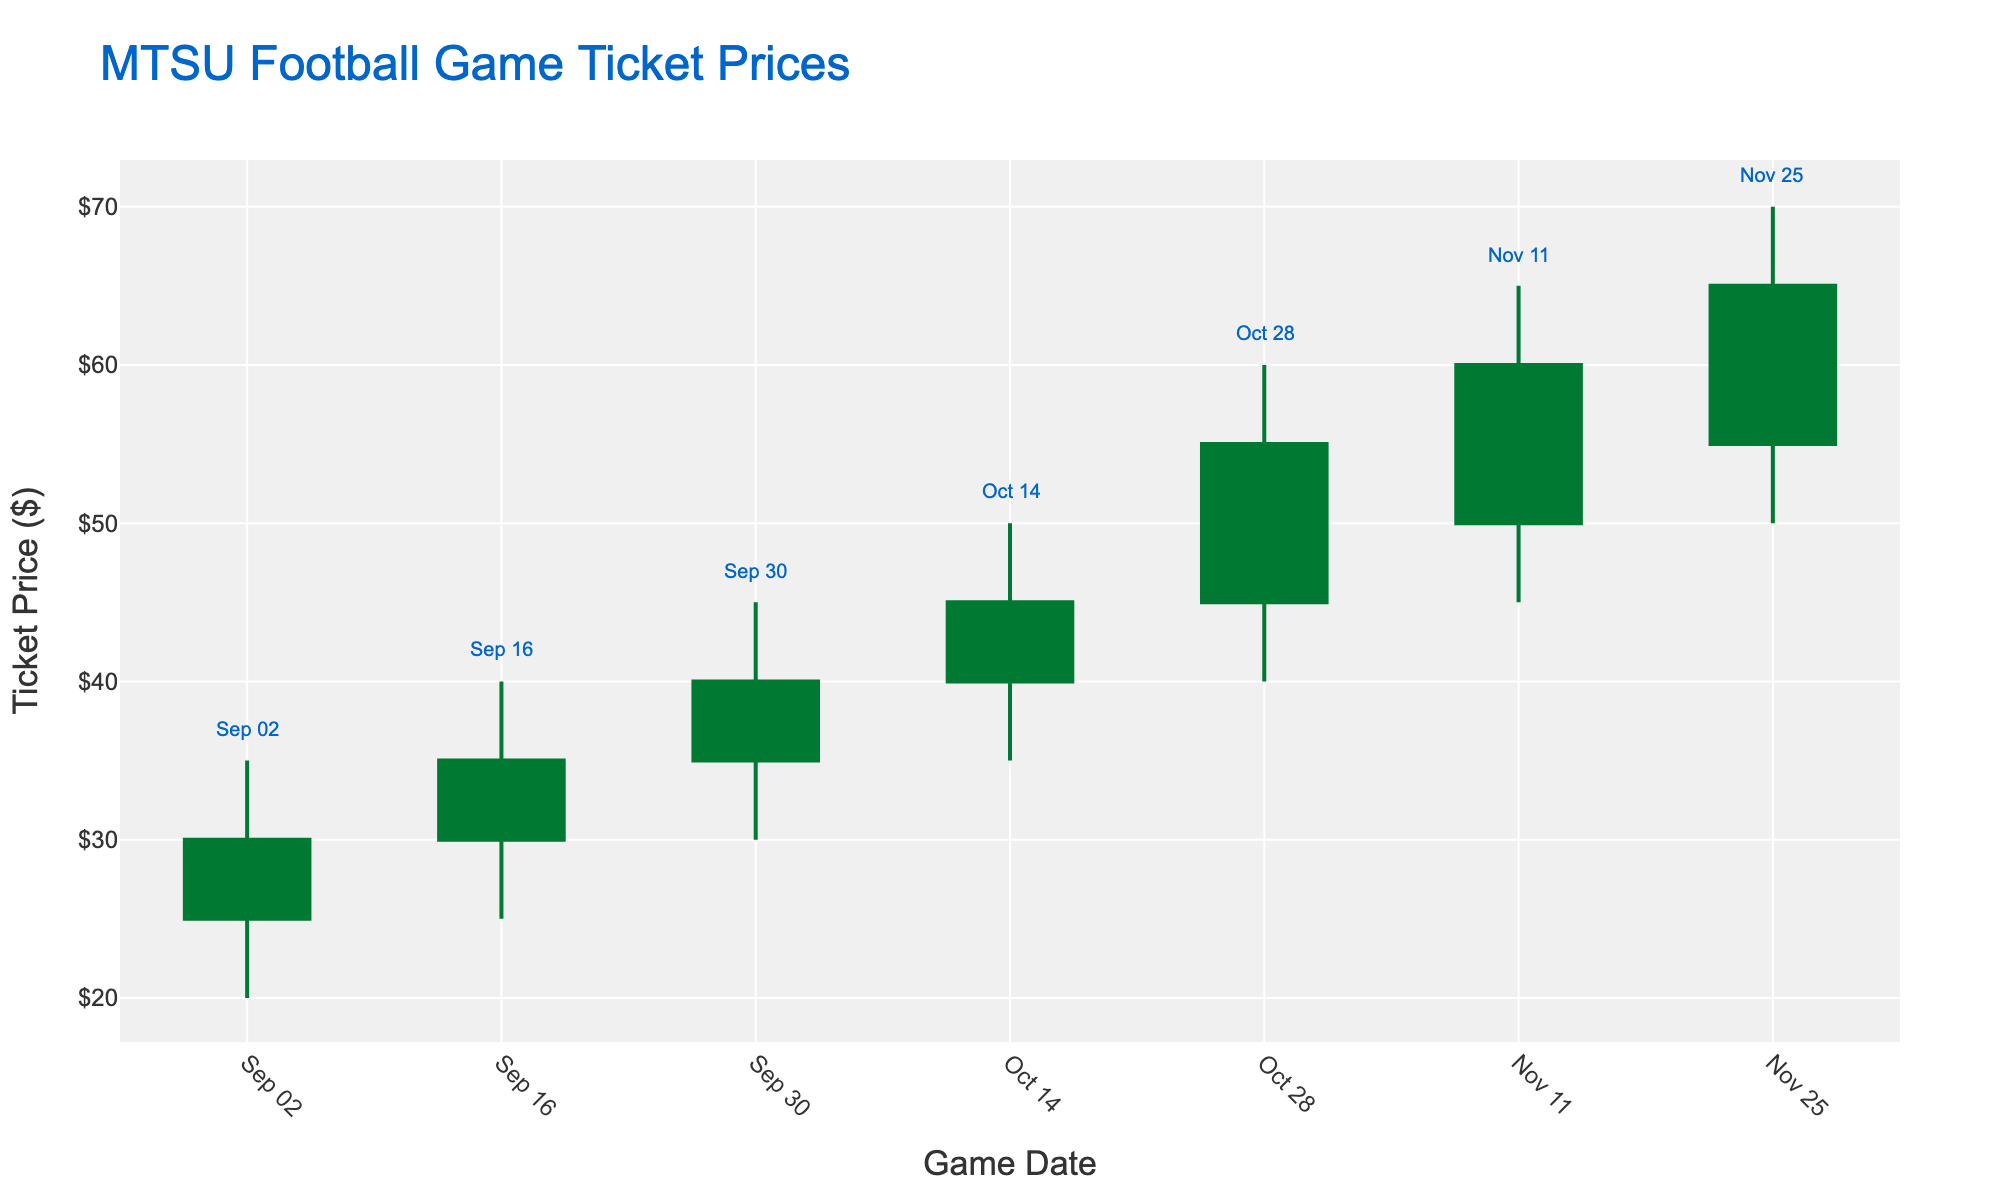How many data points are shown in the figure? Count the number of candlesticks, each representing a game date
Answer: 7 What is the title of the chart? Read the title from the top section of the chart
Answer: MTSU Football Game Ticket Prices Which game date had the highest ticket price? Identify the game date with the highest "High" point in the candlestick chart
Answer: November 25, 2023 What was the opening price for the game on October 14, 2023? Look for the candlestick corresponding to October 14, 2023, and note the "Open" value
Answer: $40 Compare the closing prices of the first and the last games of the season. What is their difference? Identify the "Close" values for September 2 and November 25, 2023, and subtract the former from the latter (65 - 30)
Answer: $35 Between which two consecutive games did the ticket price see the biggest increase in closing prices? Calculate the difference in closing prices between each pair of consecutive games and identify the maximum (55-45, between October 14 and October 28)
Answer: October 14 to October 28, 2023 What were the highest and the lowest prices for the game on November 11, 2023? Locate the candlestick corresponding to November 11, 2023, and read the "High" and "Low" values
Answer: Highest: $65, Lowest: $45 On which date did the ticket have the smallest range between the highest and lowest prices? Calculate the range (High - Low) for each date and find the minimum value (October 14, 50-35 = 15)
Answer: October 14, 2023 What was the general trend of ticket prices throughout the season? Observe the overall movement of the closing prices from the first to the last game (from $30 to $65)
Answer: Increasing How many games saw a decrease in the closing price compared to the opening price? Count the number of candlesticks where the closing price is lower than the opening price (0, no such games)
Answer: 0 